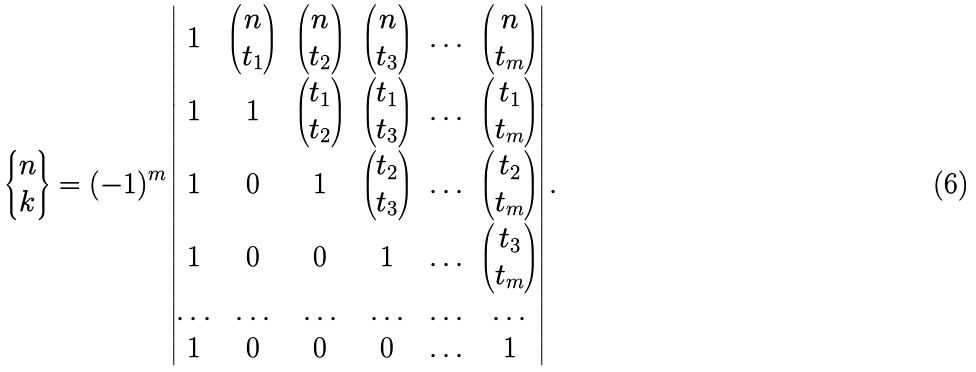Convert formula to latex. <formula><loc_0><loc_0><loc_500><loc_500>\left \{ \begin{matrix} n \\ k \end{matrix} \right \} = ( - 1 ) ^ { m } \begin{vmatrix} 1 & \begin{pmatrix} n \\ t _ { 1 } \end{pmatrix} & \begin{pmatrix} n \\ t _ { 2 } \end{pmatrix} & \begin{pmatrix} n \\ t _ { 3 } \end{pmatrix} & \hdots & \begin{pmatrix} n \\ t _ { m } \end{pmatrix} \\ 1 & 1 & \begin{pmatrix} t _ { 1 } \\ t _ { 2 } \end{pmatrix} & \begin{pmatrix} t _ { 1 } \\ t _ { 3 } \end{pmatrix} & \hdots & \begin{pmatrix} t _ { 1 } \\ t _ { m } \end{pmatrix} \\ 1 & 0 & 1 & \begin{pmatrix} t _ { 2 } \\ t _ { 3 } \end{pmatrix} & \hdots & \begin{pmatrix} t _ { 2 } \\ t _ { m } \end{pmatrix} \\ 1 & 0 & 0 & 1 & \hdots & \begin{pmatrix} t _ { 3 } \\ t _ { m } \end{pmatrix} \\ \hdots & \hdots & \hdots & \hdots & \hdots & \hdots \\ 1 & 0 & 0 & 0 & \hdots & 1 \end{vmatrix} .</formula> 